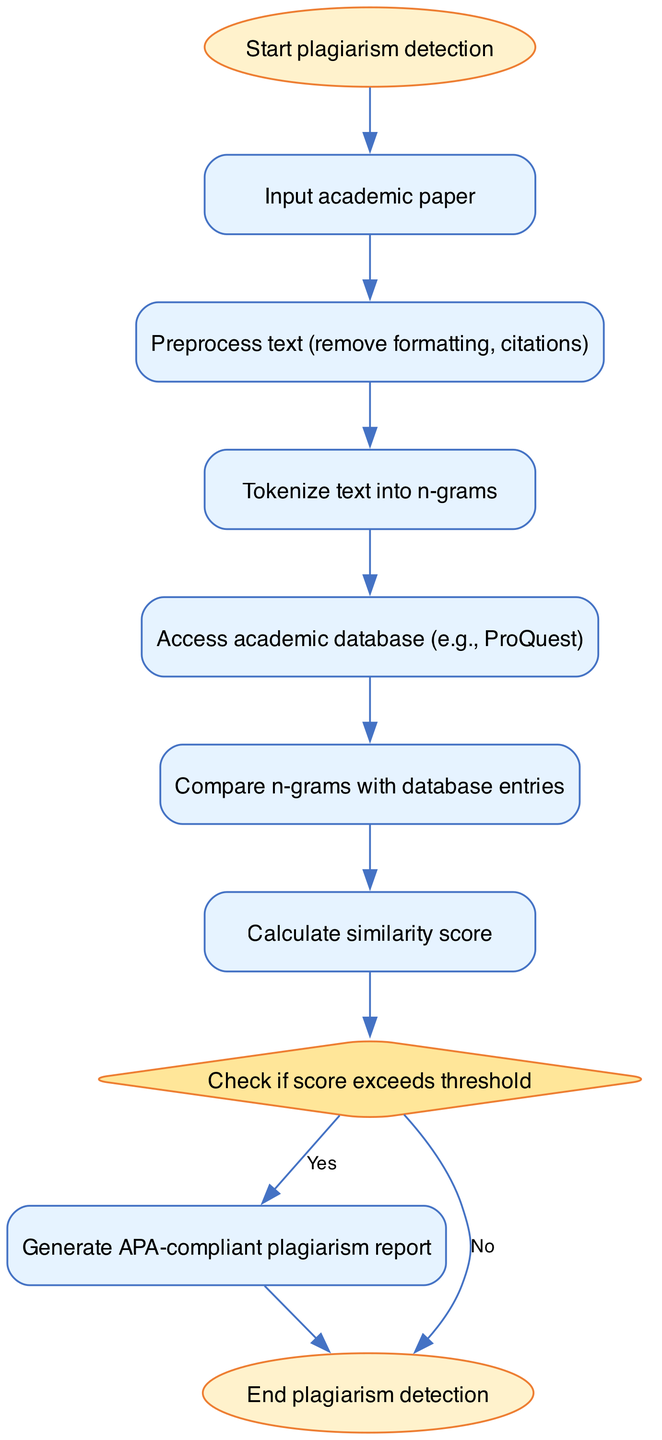What is the first step in the plagiarism detection process? The flowchart shows that the first node is labeled "Start plagiarism detection," indicating that this is the initial step of the process.
Answer: Start plagiarism detection How many nodes are present in the flowchart? Upon counting the nodes listed in the data, I found a total of ten nodes, including the start and end points.
Answer: Ten What type of node is 'threshold'? The flowchart specifies that 'threshold' is represented as a diamond shape, which is characteristic of decision points within programming flowcharts.
Answer: Diamond What action is taken after preprocessing the text? According to the directed flow in the diagram, the node following 'preprocess' is 'tokenize', indicating that the next action is tokenizing the text.
Answer: Tokenize text into n-grams If the similarity score exceeds the threshold, what is the next step? The diagram shows a directed edge from the 'threshold' node to the 'report' node for the 'Yes' condition, signifying that a report is generated if the score is above the threshold.
Answer: Generate APA-compliant plagiarism report What does the diagram conclude if the similarity score does not exceed the threshold? The flowchart indicates a directed edge from 'threshold' to 'end' for the 'No' condition, which means that if the score is not exceeded, the process will terminate at the end node.
Answer: End plagiarism detection What is the purpose of the 'database' node? The 'database' node signifies the action of accessing an academic database, which is essential for retrieving data needed for comparison in the plagiarism detection process.
Answer: Access academic database Which node follows 'score' in the process? The flowchart provides a sequential path showing that the 'threshold' node comes immediately after 'score', indicating the next step is to check against the threshold.
Answer: Check if score exceeds threshold What is the last step in the flowchart? The flow has a directed edge leading from both 'report' and 'threshold' nodes to an 'end' node, and therefore, the last step in the process is designated as 'End plagiarism detection'.
Answer: End plagiarism detection 